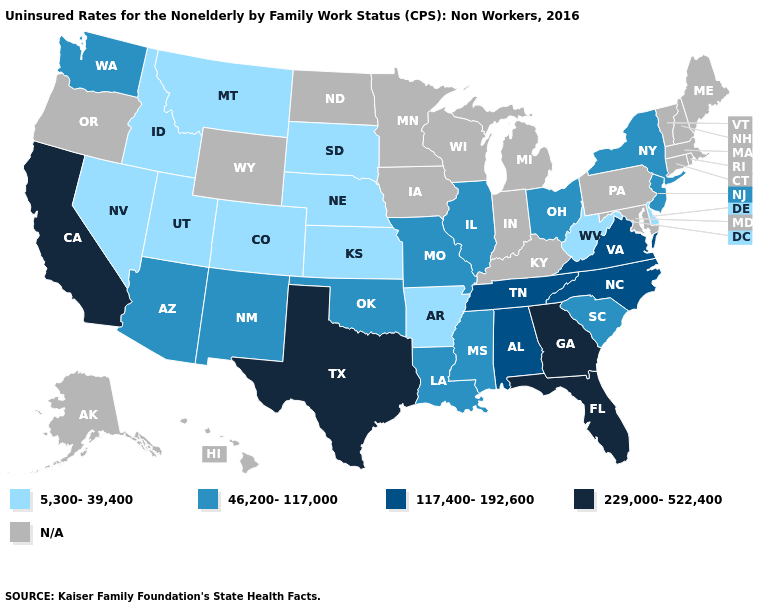Does Georgia have the highest value in the USA?
Be succinct. Yes. Name the states that have a value in the range 117,400-192,600?
Be succinct. Alabama, North Carolina, Tennessee, Virginia. Does South Carolina have the lowest value in the South?
Write a very short answer. No. What is the value of Michigan?
Short answer required. N/A. Among the states that border Texas , which have the lowest value?
Write a very short answer. Arkansas. What is the value of Alabama?
Answer briefly. 117,400-192,600. What is the value of North Carolina?
Answer briefly. 117,400-192,600. What is the value of Alabama?
Answer briefly. 117,400-192,600. Does Montana have the lowest value in the West?
Answer briefly. Yes. Which states have the lowest value in the USA?
Keep it brief. Arkansas, Colorado, Delaware, Idaho, Kansas, Montana, Nebraska, Nevada, South Dakota, Utah, West Virginia. What is the value of Wisconsin?
Be succinct. N/A. What is the value of Pennsylvania?
Be succinct. N/A. Does Florida have the highest value in the South?
Be succinct. Yes. What is the lowest value in the South?
Write a very short answer. 5,300-39,400. What is the lowest value in the Northeast?
Give a very brief answer. 46,200-117,000. 